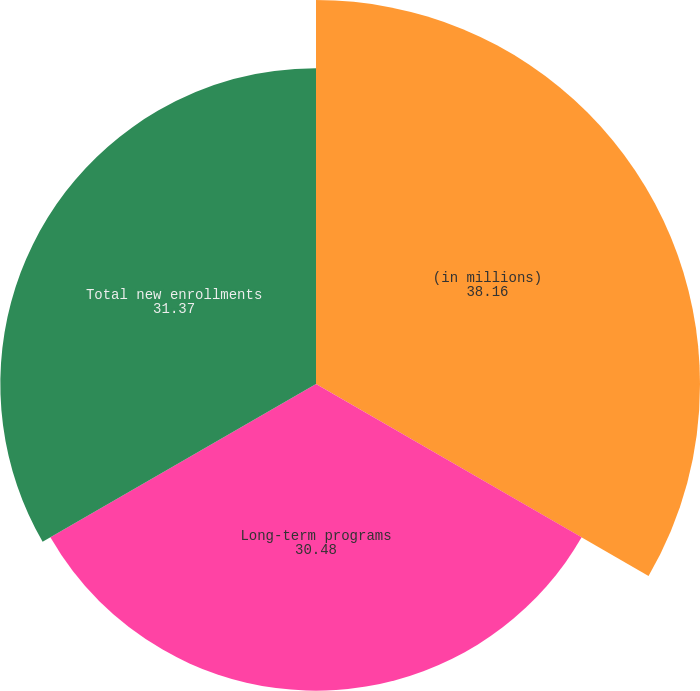Convert chart. <chart><loc_0><loc_0><loc_500><loc_500><pie_chart><fcel>(in millions)<fcel>Long-term programs<fcel>Total new enrollments<nl><fcel>38.16%<fcel>30.48%<fcel>31.37%<nl></chart> 